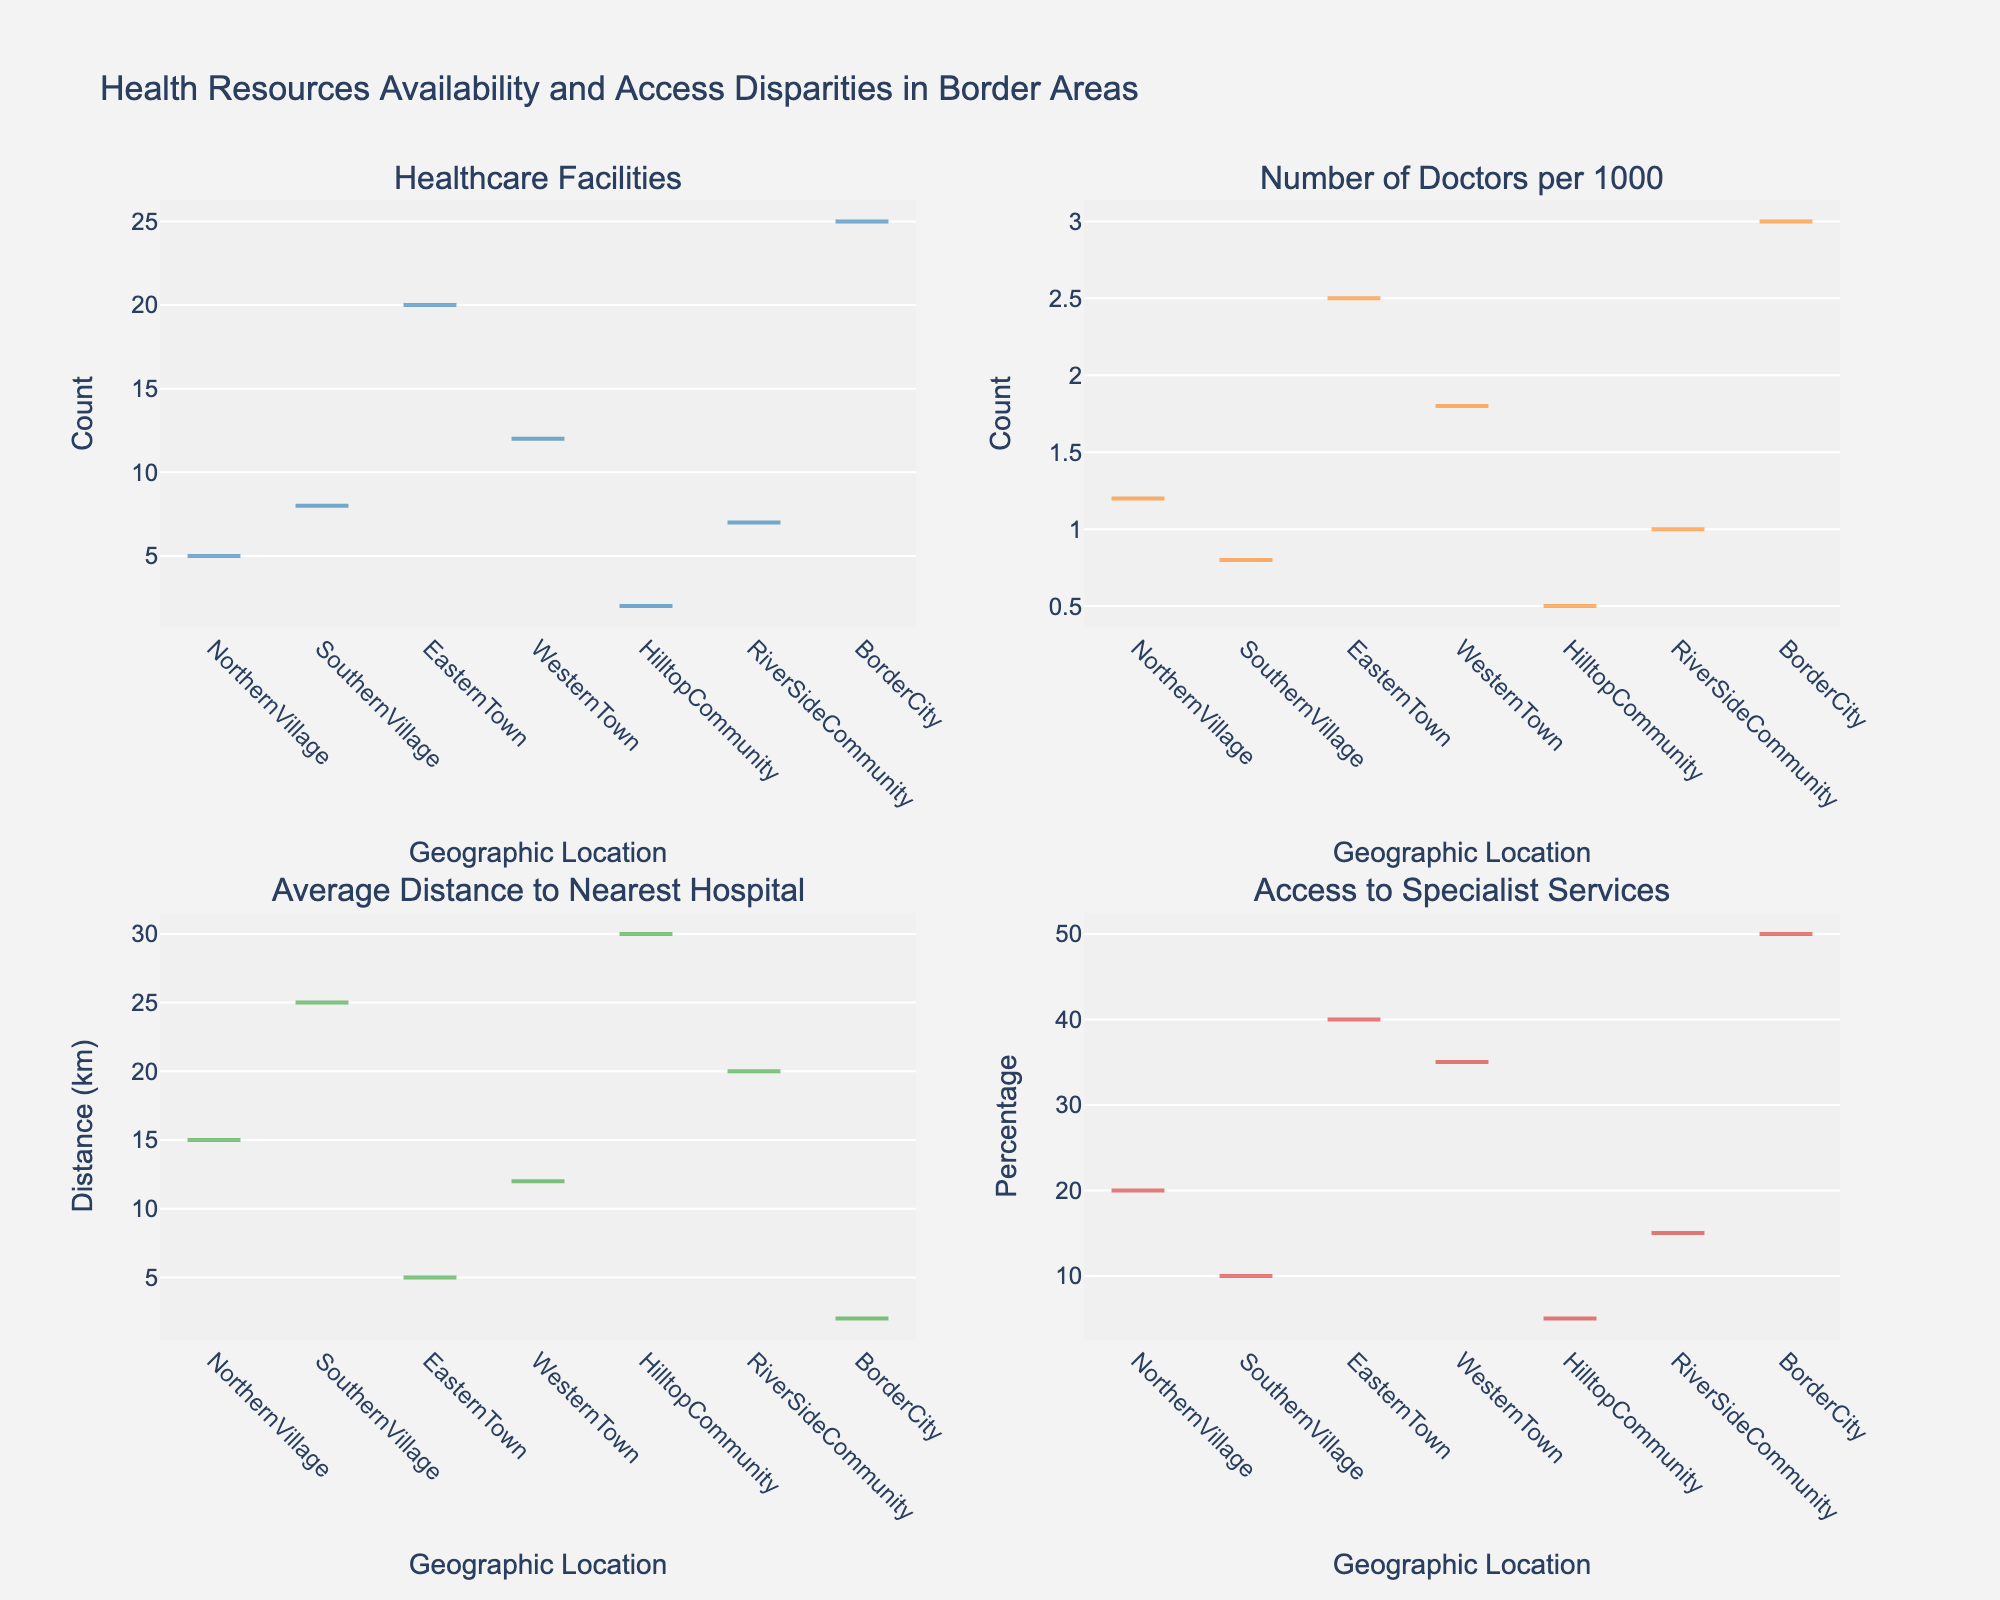Which geographic location has the highest number of healthcare facilities? By looking at the subplot for "Healthcare Facilities," we can observe that the border city has the highest number.
Answer: Border City Which region has the lowest number of doctors per 1000 residents? By checking the subplot for "Number of Doctors per 1000," the Hilltop Community shows the lowest value.
Answer: Hilltop Community What is the average distance to the nearest hospital for the Northern and Southern Villages combined? From the subplot for "Average Distance to Nearest Hospital," the Northern Village has a distance of 15 km, and the Southern Village has 25 km. The average is (15 + 25) / 2 = 20 km.
Answer: 20 km Compare the access to specialist services between the Eastern and Western Towns. By examining the subplot for "Access to Specialist Services," we see the Eastern Town has 40% access, while the Western Town has 35% access.
Answer: Eastern Town has higher access What geographic location has the smallest average distance to the nearest hospital? By looking at the subplot for "Average Distance to Nearest Hospital," the Border City has the smallest distance, which is 2 km.
Answer: Border City What is the combined percentage of access to specialist services for the RiverSide Community and Northern Village? From the subplot for "Access to Specialist Services," RiverSide Community has 15%, and Northern Village has 20%. So, combined percentage is 15% + 20% = 35%.
Answer: 35% What is the difference in population density between the Hilltop Community and Border City? From the data subplot, Hilltop Community has a density of 20 people per km², and Border City has 500. The difference is 500 - 20 = 480 people per km².
Answer: 480 people per km² 